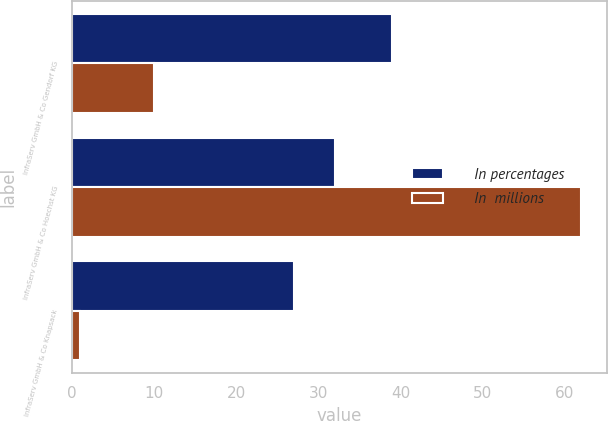Convert chart. <chart><loc_0><loc_0><loc_500><loc_500><stacked_bar_chart><ecel><fcel>InfraServ GmbH & Co Gendorf KG<fcel>InfraServ GmbH & Co Hoechst KG<fcel>InfraServ GmbH & Co Knapsack<nl><fcel>In percentages<fcel>39<fcel>32<fcel>27<nl><fcel>In  millions<fcel>10<fcel>62<fcel>1<nl></chart> 